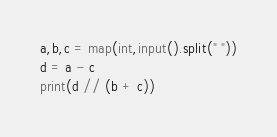<code> <loc_0><loc_0><loc_500><loc_500><_Python_>a,b,c = map(int,input().split(" "))
d = a - c
print(d // (b + c))
</code> 